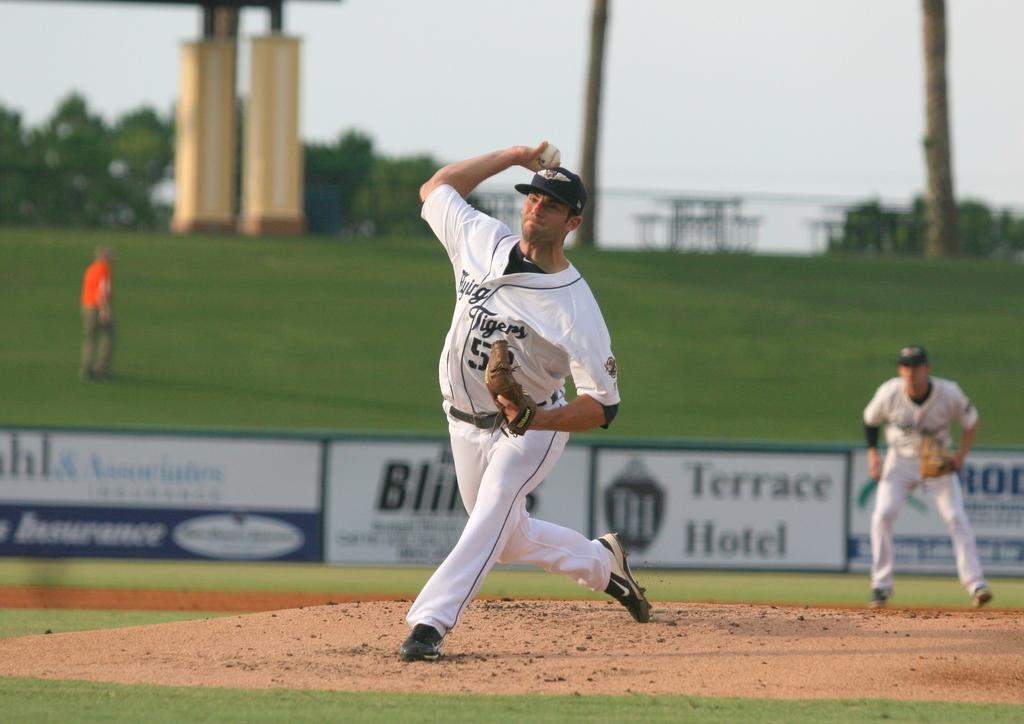<image>
Share a concise interpretation of the image provided. One of the sponsors of the baseball stadium is the Terrace Hotel. 